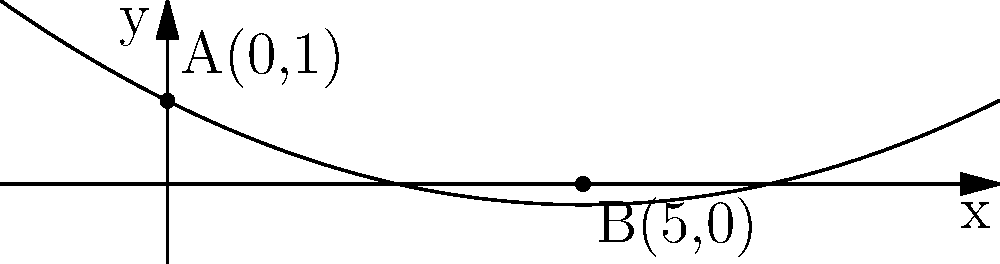In spinal analysis, a patient's spine curvature is modeled by the function $f(x) = 0.05x^2 - 0.5x + 1$, where $x$ represents the horizontal distance (in cm) from the base of the spine, and $f(x)$ represents the vertical displacement (in cm). Points A(0,1) and B(5,0) are identified on the curve. Calculate the angle (in degrees) between the tangent lines at these two points to assess the severity of the spinal curvature. To find the angle between the tangent lines at points A and B, we need to follow these steps:

1. Find the derivative of the function:
   $f'(x) = 0.1x - 0.5$

2. Calculate the slopes of the tangent lines at points A and B:
   At A(0,1): $m_A = f'(0) = 0.1(0) - 0.5 = -0.5$
   At B(5,0): $m_B = f'(5) = 0.1(5) - 0.5 = 0$

3. Use the formula for the angle between two lines:
   $\tan \theta = |\frac{m_1 - m_2}{1 + m_1m_2}|$

4. Substitute the values:
   $\tan \theta = |\frac{-0.5 - 0}{1 + (-0.5)(0)}| = 0.5$

5. Take the inverse tangent (arctangent) and convert to degrees:
   $\theta = \arctan(0.5) \approx 0.4636$ radians
   $\theta \approx 0.4636 \times \frac{180}{\pi} \approx 26.57°$

The angle between the tangent lines at points A and B is approximately 26.57°.
Answer: 26.57° 